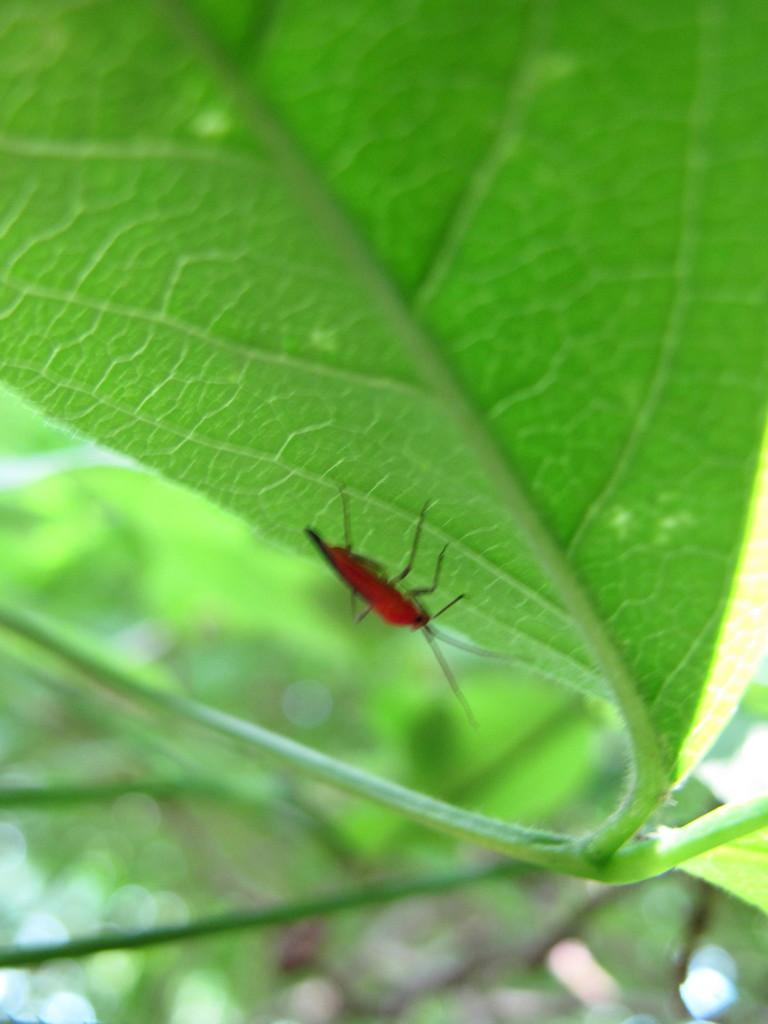What type of creature can be seen in the image? There is an insect in the image. Where is the insect located in the image? The insect is on a leaf. What type of collar can be seen on the insect in the image? There is no collar present on the insect in the image. What is the insect doing that might cause someone to laugh in the image? The insect is not performing any actions that would cause someone to laugh in the image. 